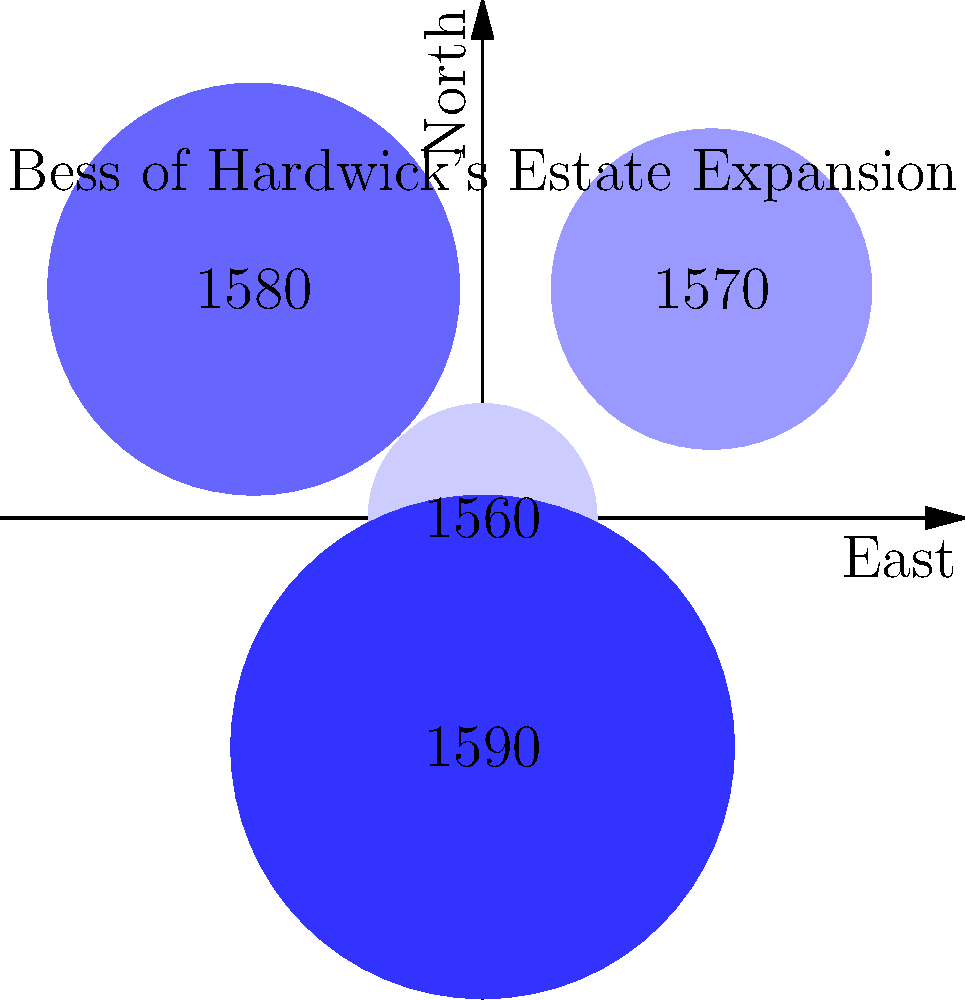Based on the map overlay showing the expansion of Bess of Hardwick's estates over time, in which decade did her landholdings appear to increase most significantly in size? To determine the decade when Bess of Hardwick's estates increased most significantly, we need to analyze the map overlay:

1. The map shows four circular regions representing Bess's estates at different times.
2. Each circle is labeled with a year, starting from 1550 and increasing by 10 years each time.
3. The circles are color-coded, with darker shades representing later acquisitions.
4. The size of each circle represents the relative size of the estate at that time.

Analyzing the expansion:
1. 1550: Smallest circle, representing the initial estate.
2. 1560: Slightly larger circle, showing some growth.
3. 1570: Noticeably larger circle, indicating significant expansion.
4. 1580: Largest circle, but the increase in size from 1570 is less dramatic than the increase from 1560 to 1570.

The most significant increase in size appears to be between 1560 and 1570, as the circle for 1570 is considerably larger than the one for 1560.
Answer: 1560s 